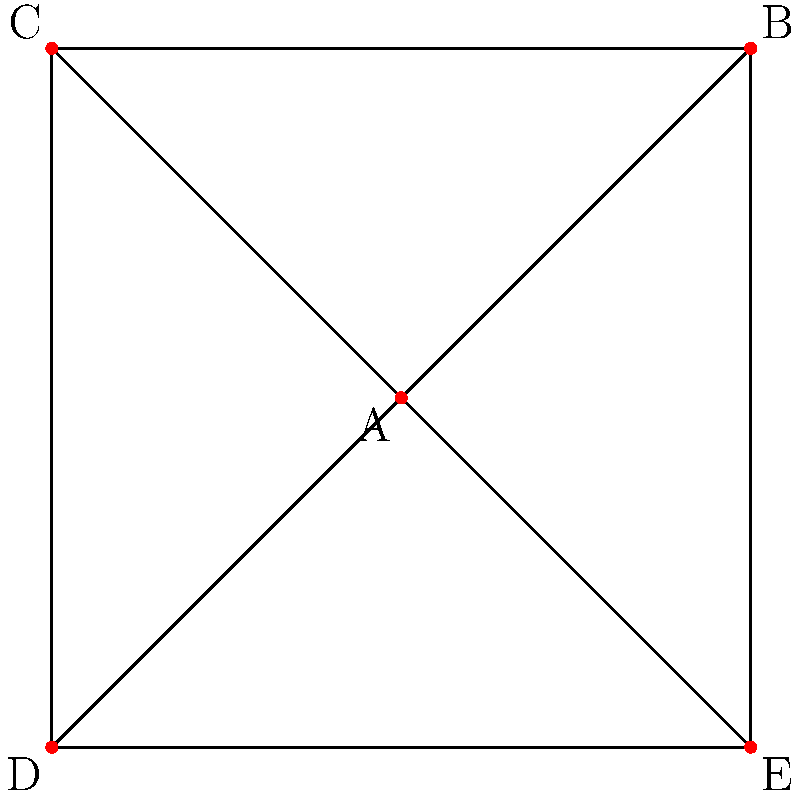As a local artist tasked with designing fan zones in a football stadium, you're presented with a graph representing different sections that need to be colored. Each vertex represents a fan zone, and edges connect adjacent zones. What is the chromatic number of this graph, ensuring that no two adjacent zones have the same color? To determine the chromatic number of this graph, we'll follow these steps:

1. Observe that the graph is a complete graph $K_5$, where every vertex is connected to every other vertex.

2. In a complete graph $K_n$, each vertex must have a different color because it's adjacent to all other vertices.

3. The number of vertices in this graph is 5 (A, B, C, D, and E).

4. Therefore, we need at least 5 different colors to properly color this graph.

5. The chromatic number $\chi(G)$ of a graph G is defined as the minimum number of colors needed to color the vertices of G such that no two adjacent vertices share the same color.

6. For a complete graph $K_n$, the chromatic number is always equal to n.

7. In this case, $\chi(K_5) = 5$.

This means that to ensure no two adjacent fan zones have the same color, we need exactly 5 different colors.
Answer: 5 